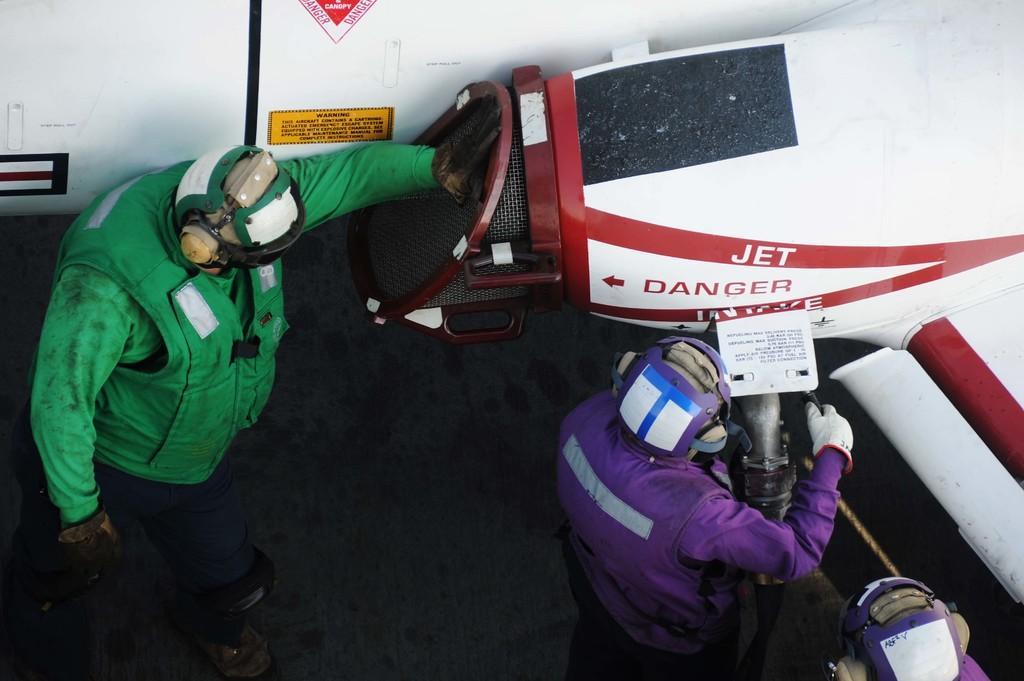In one or two sentences, can you explain what this image depicts? In this image we can see three persons wearing the helmets. We can also see the jet and there is also a text on the jet. We can also see the surface. 